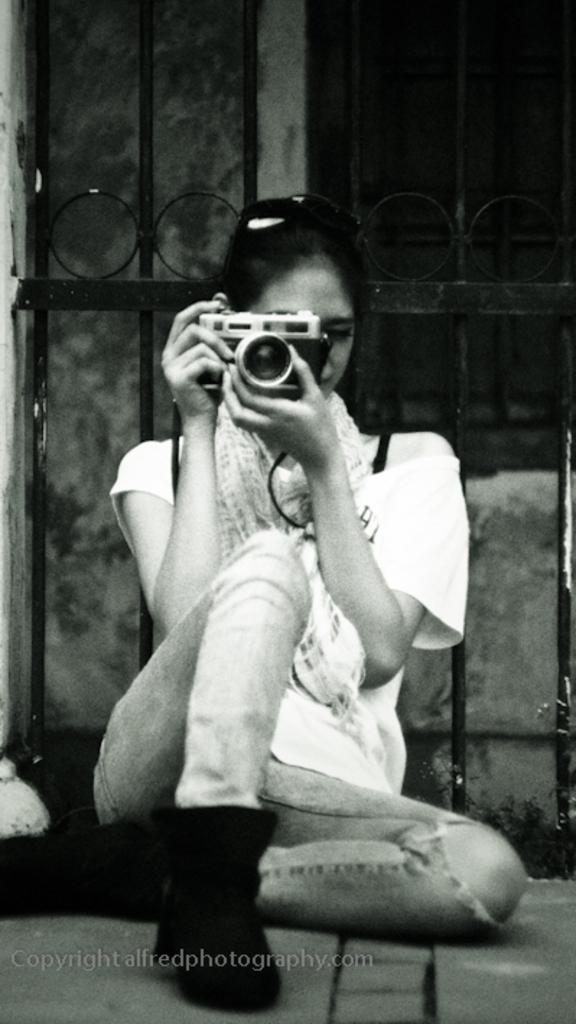What is the main subject of the image? The main subject of the image is a woman. What is the woman holding in the image? The woman is holding a camera. What type of riddle is the woman discussing with the crowd in the image? There is no riddle or crowd present in the image; it only features a woman holding a camera. 